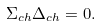<formula> <loc_0><loc_0><loc_500><loc_500>\Sigma _ { c h } \Delta _ { c h } = 0 .</formula> 